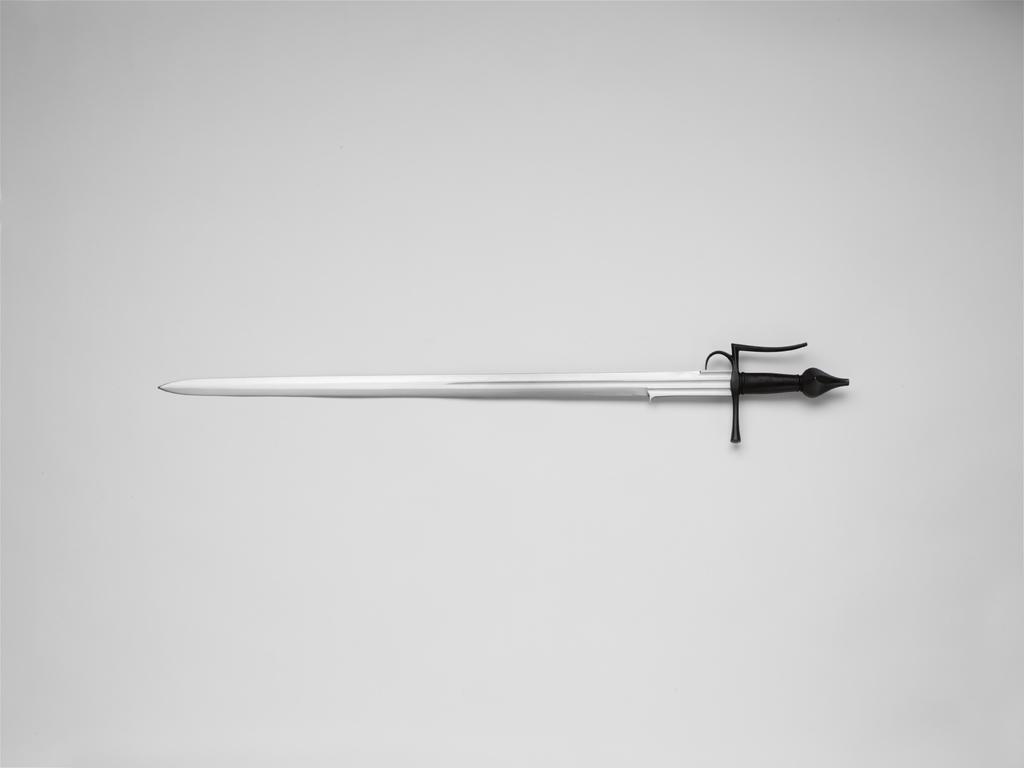Can you describe this image briefly? In this image there is a sword in the middle, and there is a white color background. 